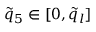Convert formula to latex. <formula><loc_0><loc_0><loc_500><loc_500>\tilde { q } _ { 5 } \in [ 0 , \tilde { q } _ { l } ]</formula> 